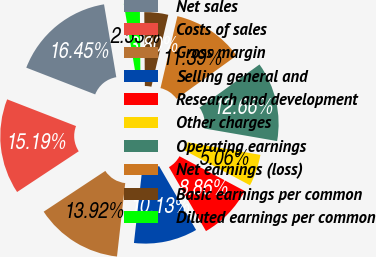Convert chart. <chart><loc_0><loc_0><loc_500><loc_500><pie_chart><fcel>Net sales<fcel>Costs of sales<fcel>Gross margin<fcel>Selling general and<fcel>Research and development<fcel>Other charges<fcel>Operating earnings<fcel>Net earnings (loss)<fcel>Basic earnings per common<fcel>Diluted earnings per common<nl><fcel>16.45%<fcel>15.19%<fcel>13.92%<fcel>10.13%<fcel>8.86%<fcel>5.06%<fcel>12.66%<fcel>11.39%<fcel>3.8%<fcel>2.53%<nl></chart> 